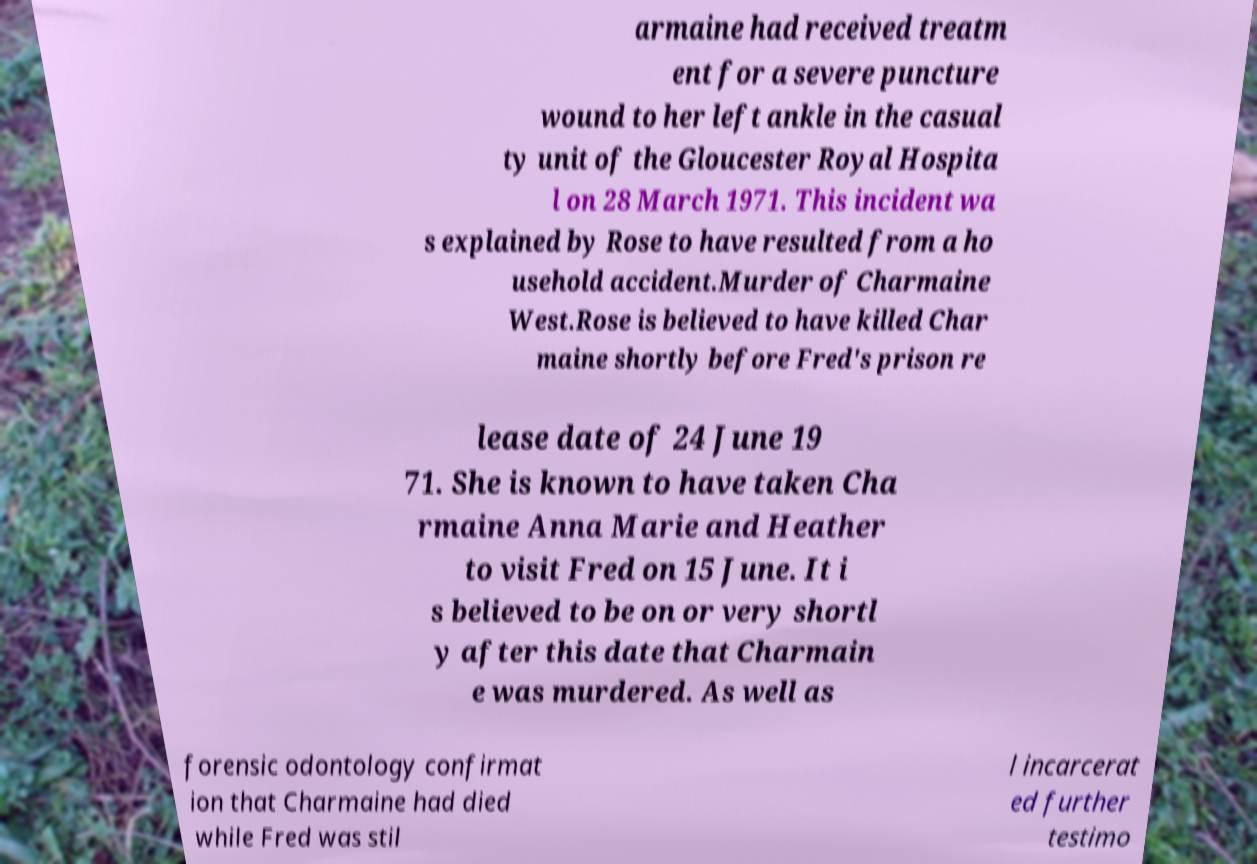Please read and relay the text visible in this image. What does it say? armaine had received treatm ent for a severe puncture wound to her left ankle in the casual ty unit of the Gloucester Royal Hospita l on 28 March 1971. This incident wa s explained by Rose to have resulted from a ho usehold accident.Murder of Charmaine West.Rose is believed to have killed Char maine shortly before Fred's prison re lease date of 24 June 19 71. She is known to have taken Cha rmaine Anna Marie and Heather to visit Fred on 15 June. It i s believed to be on or very shortl y after this date that Charmain e was murdered. As well as forensic odontology confirmat ion that Charmaine had died while Fred was stil l incarcerat ed further testimo 